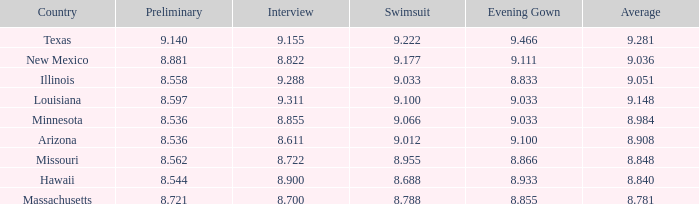What was the average score for the country with the evening gown score of 9.100? 1.0. 